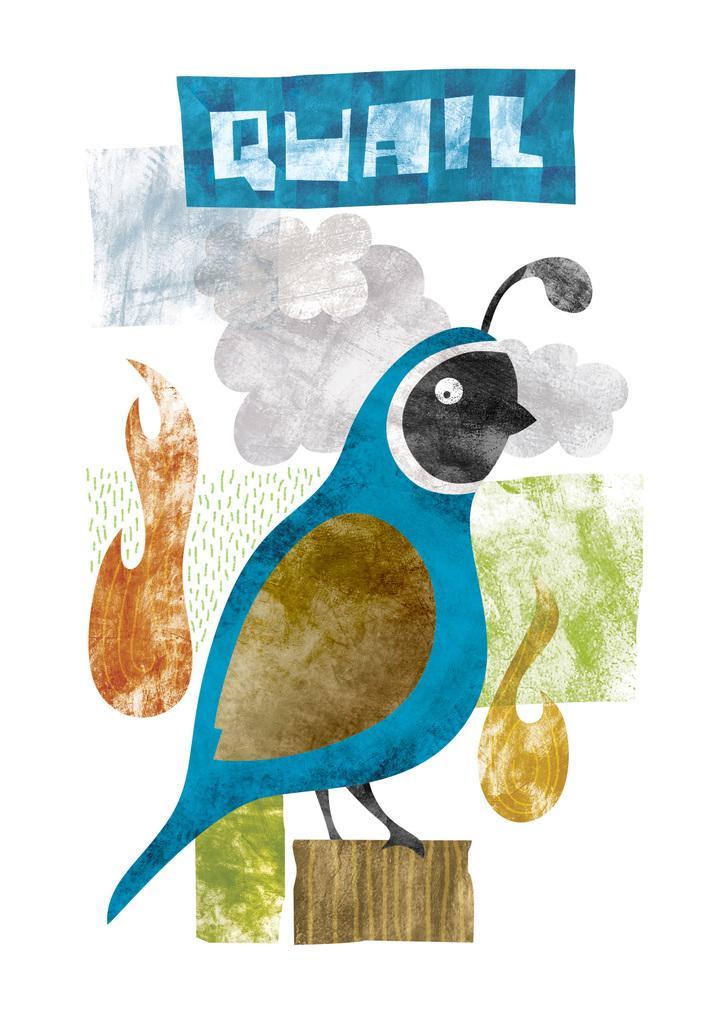Can you describe this image briefly? In this image I can see a drawing of a bird. There are clouds in the sky and some text is written at the top. 